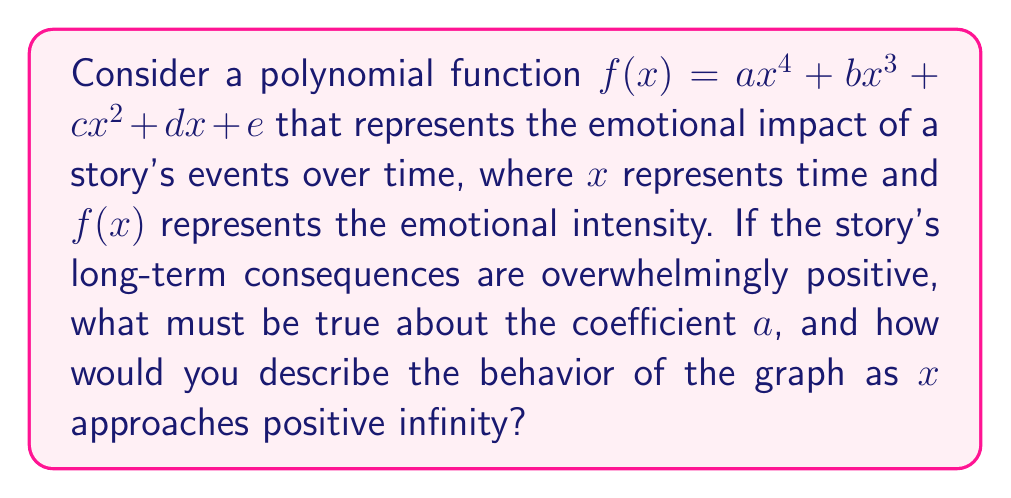Provide a solution to this math problem. 1. The behavior of a polynomial function as $x$ approaches infinity is determined by its leading term, which is the term with the highest degree.

2. In this case, the leading term is $ax^4$.

3. For the story's long-term consequences to be overwhelmingly positive, the graph should increase without bound as $x$ increases.

4. This means that as $x$ approaches positive infinity, $f(x)$ should also approach positive infinity.

5. For a fourth-degree polynomial, this occurs when the coefficient of the leading term (a) is positive.

6. When $a > 0$, as $x \to +\infty$, $ax^4 \to +\infty$, and it dominates all lower-degree terms.

7. The graph's behavior can be described using limit notation:

   $$\lim_{x \to +\infty} f(x) = +\infty$$

8. Visually, this means the graph will eventually rise steeply and continuously as $x$ increases, resembling an upward-opening parabola but rising even more rapidly.
Answer: $a > 0$; $\lim_{x \to +\infty} f(x) = +\infty$ 